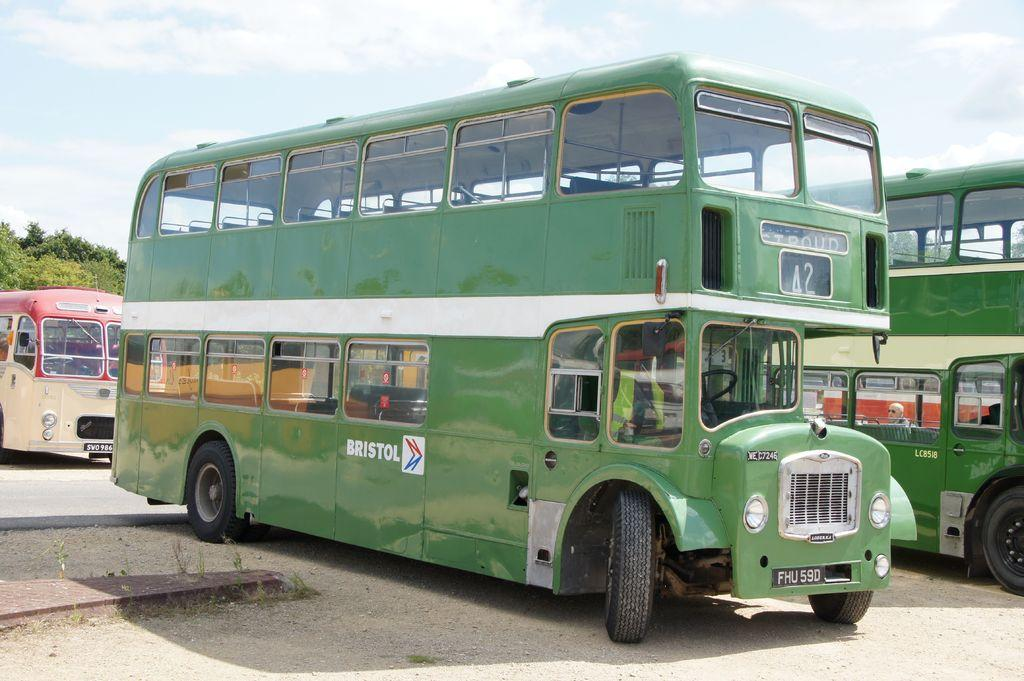Provide a one-sentence caption for the provided image. A green double Decker bus has the word Bristol painted on the side. 